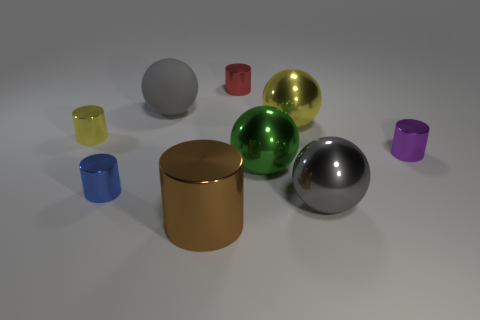What is the shape of the object that appears to be the largest in the image? The shape of the largest object in the image is cylindrical. It has a broad, round base, a height that is shorter than its diameter, and a flat top surface. 